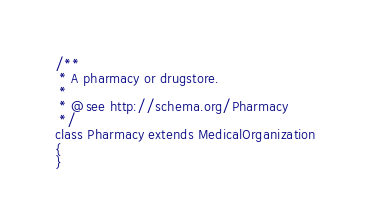<code> <loc_0><loc_0><loc_500><loc_500><_PHP_>/**
 * A pharmacy or drugstore.
 *
 * @see http://schema.org/Pharmacy
 */
class Pharmacy extends MedicalOrganization
{
}
</code> 